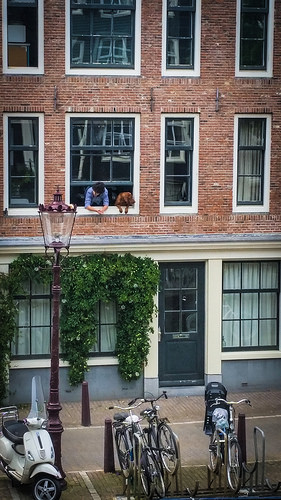<image>
Is the bike on the rack? Yes. Looking at the image, I can see the bike is positioned on top of the rack, with the rack providing support. Where is the bicycle in relation to the dog? Is it next to the dog? No. The bicycle is not positioned next to the dog. They are located in different areas of the scene. 